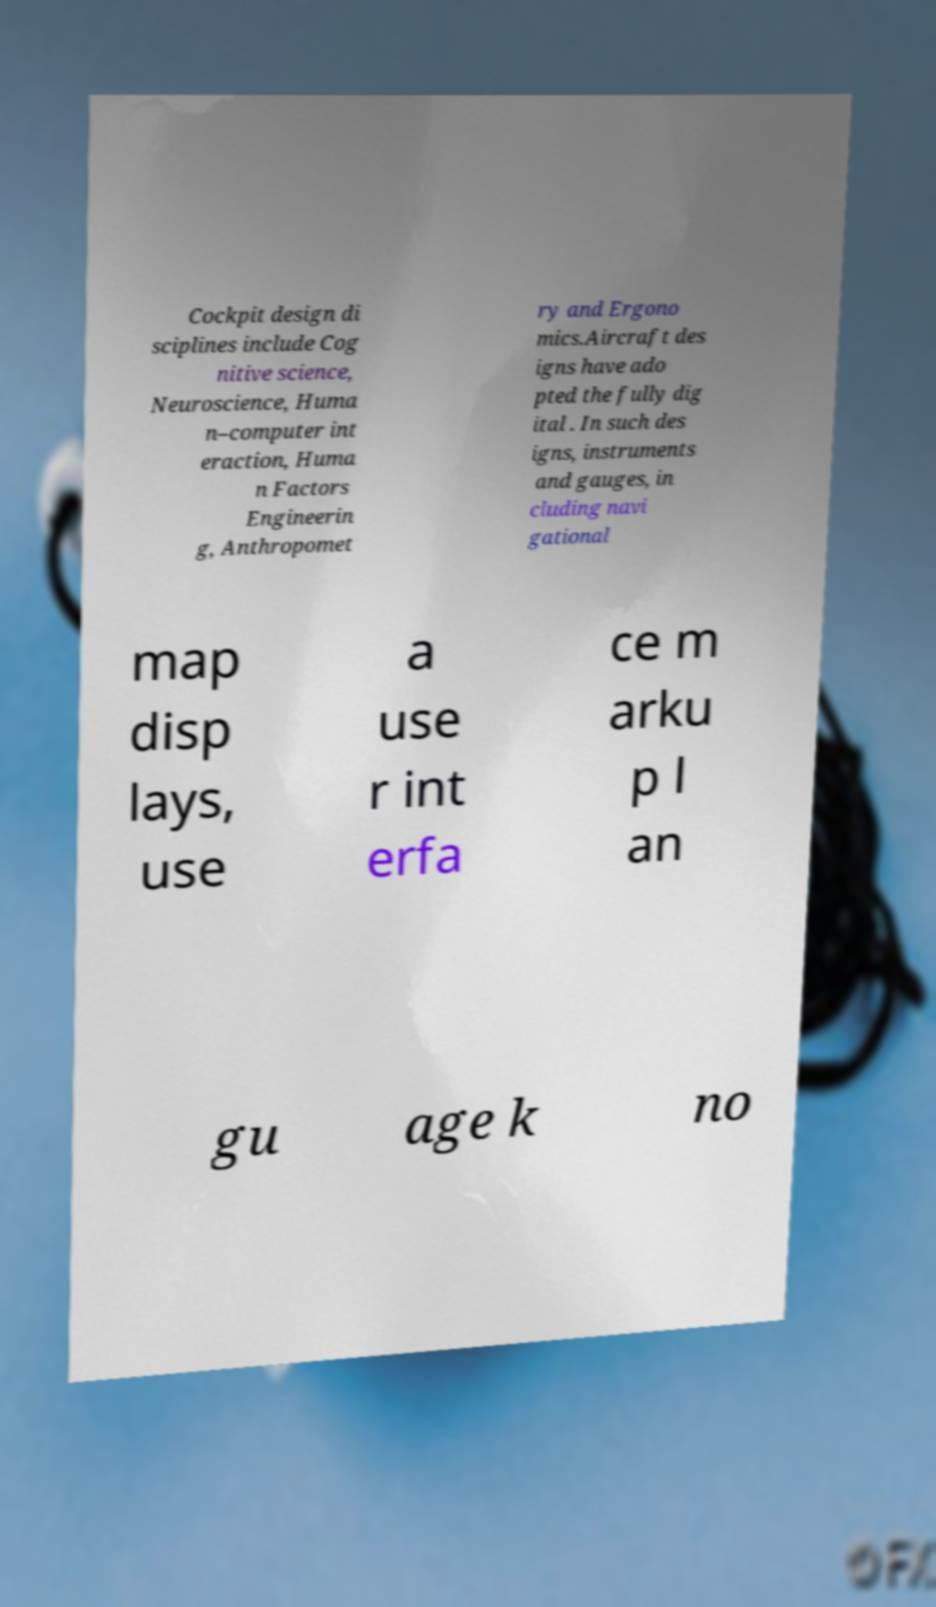Could you extract and type out the text from this image? Cockpit design di sciplines include Cog nitive science, Neuroscience, Huma n–computer int eraction, Huma n Factors Engineerin g, Anthropomet ry and Ergono mics.Aircraft des igns have ado pted the fully dig ital . In such des igns, instruments and gauges, in cluding navi gational map disp lays, use a use r int erfa ce m arku p l an gu age k no 